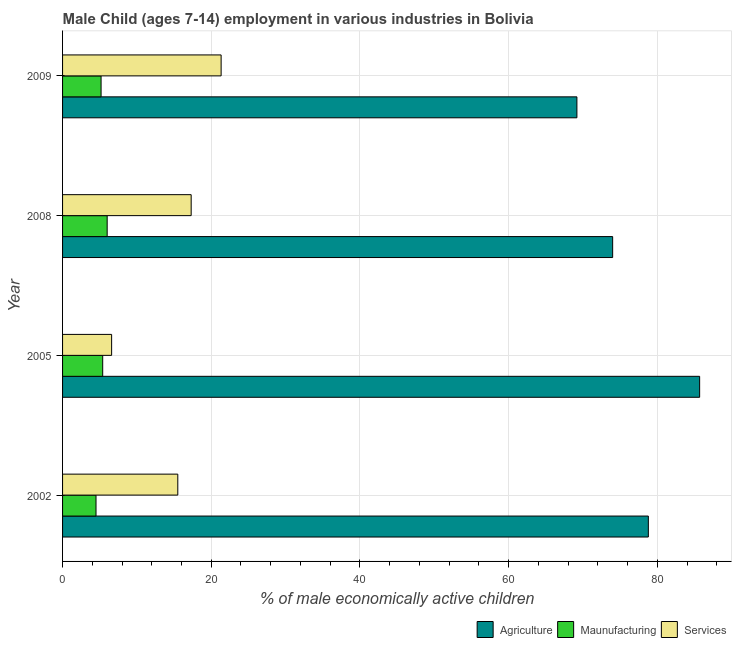How many different coloured bars are there?
Your answer should be very brief. 3. How many groups of bars are there?
Provide a short and direct response. 4. Are the number of bars on each tick of the Y-axis equal?
Offer a terse response. Yes. How many bars are there on the 4th tick from the bottom?
Your response must be concise. 3. What is the label of the 3rd group of bars from the top?
Your response must be concise. 2005. What is the percentage of economically active children in agriculture in 2009?
Your response must be concise. 69.19. Across all years, what is the minimum percentage of economically active children in agriculture?
Offer a very short reply. 69.19. In which year was the percentage of economically active children in agriculture maximum?
Provide a short and direct response. 2005. In which year was the percentage of economically active children in agriculture minimum?
Give a very brief answer. 2009. What is the total percentage of economically active children in services in the graph?
Provide a succinct answer. 60.73. What is the difference between the percentage of economically active children in services in 2002 and that in 2005?
Keep it short and to the point. 8.9. What is the difference between the percentage of economically active children in services in 2009 and the percentage of economically active children in agriculture in 2005?
Your answer should be compact. -64.37. What is the average percentage of economically active children in manufacturing per year?
Your response must be concise. 5.27. In the year 2002, what is the difference between the percentage of economically active children in services and percentage of economically active children in agriculture?
Keep it short and to the point. -63.3. What is the ratio of the percentage of economically active children in manufacturing in 2002 to that in 2008?
Make the answer very short. 0.75. Is the difference between the percentage of economically active children in manufacturing in 2008 and 2009 greater than the difference between the percentage of economically active children in services in 2008 and 2009?
Your answer should be very brief. Yes. What is the difference between the highest and the second highest percentage of economically active children in services?
Provide a short and direct response. 4.03. What is the difference between the highest and the lowest percentage of economically active children in agriculture?
Offer a very short reply. 16.51. Is the sum of the percentage of economically active children in agriculture in 2002 and 2008 greater than the maximum percentage of economically active children in services across all years?
Provide a short and direct response. Yes. What does the 2nd bar from the top in 2009 represents?
Your response must be concise. Maunufacturing. What does the 2nd bar from the bottom in 2009 represents?
Ensure brevity in your answer.  Maunufacturing. Is it the case that in every year, the sum of the percentage of economically active children in agriculture and percentage of economically active children in manufacturing is greater than the percentage of economically active children in services?
Ensure brevity in your answer.  Yes. Are all the bars in the graph horizontal?
Your answer should be compact. Yes. How many years are there in the graph?
Your response must be concise. 4. What is the difference between two consecutive major ticks on the X-axis?
Offer a terse response. 20. Does the graph contain grids?
Ensure brevity in your answer.  Yes. How many legend labels are there?
Your response must be concise. 3. What is the title of the graph?
Your answer should be compact. Male Child (ages 7-14) employment in various industries in Bolivia. Does "Infant(female)" appear as one of the legend labels in the graph?
Keep it short and to the point. No. What is the label or title of the X-axis?
Ensure brevity in your answer.  % of male economically active children. What is the label or title of the Y-axis?
Provide a short and direct response. Year. What is the % of male economically active children of Agriculture in 2002?
Make the answer very short. 78.8. What is the % of male economically active children in Services in 2002?
Provide a succinct answer. 15.5. What is the % of male economically active children of Agriculture in 2005?
Make the answer very short. 85.7. What is the % of male economically active children of Maunufacturing in 2005?
Provide a succinct answer. 5.4. What is the % of male economically active children of Services in 2005?
Provide a short and direct response. 6.6. What is the % of male economically active children of Agriculture in 2009?
Offer a terse response. 69.19. What is the % of male economically active children in Maunufacturing in 2009?
Your response must be concise. 5.18. What is the % of male economically active children of Services in 2009?
Your answer should be very brief. 21.33. Across all years, what is the maximum % of male economically active children of Agriculture?
Keep it short and to the point. 85.7. Across all years, what is the maximum % of male economically active children in Maunufacturing?
Keep it short and to the point. 6. Across all years, what is the maximum % of male economically active children of Services?
Ensure brevity in your answer.  21.33. Across all years, what is the minimum % of male economically active children in Agriculture?
Offer a very short reply. 69.19. What is the total % of male economically active children of Agriculture in the graph?
Offer a terse response. 307.69. What is the total % of male economically active children of Maunufacturing in the graph?
Give a very brief answer. 21.08. What is the total % of male economically active children of Services in the graph?
Provide a succinct answer. 60.73. What is the difference between the % of male economically active children in Agriculture in 2002 and that in 2005?
Offer a very short reply. -6.9. What is the difference between the % of male economically active children in Agriculture in 2002 and that in 2008?
Your answer should be compact. 4.8. What is the difference between the % of male economically active children of Services in 2002 and that in 2008?
Your response must be concise. -1.8. What is the difference between the % of male economically active children in Agriculture in 2002 and that in 2009?
Keep it short and to the point. 9.61. What is the difference between the % of male economically active children in Maunufacturing in 2002 and that in 2009?
Offer a terse response. -0.68. What is the difference between the % of male economically active children of Services in 2002 and that in 2009?
Keep it short and to the point. -5.83. What is the difference between the % of male economically active children of Agriculture in 2005 and that in 2008?
Offer a very short reply. 11.7. What is the difference between the % of male economically active children of Maunufacturing in 2005 and that in 2008?
Your answer should be very brief. -0.6. What is the difference between the % of male economically active children of Services in 2005 and that in 2008?
Offer a terse response. -10.7. What is the difference between the % of male economically active children of Agriculture in 2005 and that in 2009?
Give a very brief answer. 16.51. What is the difference between the % of male economically active children in Maunufacturing in 2005 and that in 2009?
Provide a short and direct response. 0.22. What is the difference between the % of male economically active children of Services in 2005 and that in 2009?
Your answer should be very brief. -14.73. What is the difference between the % of male economically active children in Agriculture in 2008 and that in 2009?
Keep it short and to the point. 4.81. What is the difference between the % of male economically active children of Maunufacturing in 2008 and that in 2009?
Offer a very short reply. 0.82. What is the difference between the % of male economically active children in Services in 2008 and that in 2009?
Provide a short and direct response. -4.03. What is the difference between the % of male economically active children in Agriculture in 2002 and the % of male economically active children in Maunufacturing in 2005?
Provide a short and direct response. 73.4. What is the difference between the % of male economically active children in Agriculture in 2002 and the % of male economically active children in Services in 2005?
Ensure brevity in your answer.  72.2. What is the difference between the % of male economically active children in Maunufacturing in 2002 and the % of male economically active children in Services in 2005?
Keep it short and to the point. -2.1. What is the difference between the % of male economically active children of Agriculture in 2002 and the % of male economically active children of Maunufacturing in 2008?
Offer a very short reply. 72.8. What is the difference between the % of male economically active children in Agriculture in 2002 and the % of male economically active children in Services in 2008?
Ensure brevity in your answer.  61.5. What is the difference between the % of male economically active children in Agriculture in 2002 and the % of male economically active children in Maunufacturing in 2009?
Give a very brief answer. 73.62. What is the difference between the % of male economically active children of Agriculture in 2002 and the % of male economically active children of Services in 2009?
Make the answer very short. 57.47. What is the difference between the % of male economically active children of Maunufacturing in 2002 and the % of male economically active children of Services in 2009?
Your answer should be very brief. -16.83. What is the difference between the % of male economically active children of Agriculture in 2005 and the % of male economically active children of Maunufacturing in 2008?
Keep it short and to the point. 79.7. What is the difference between the % of male economically active children of Agriculture in 2005 and the % of male economically active children of Services in 2008?
Keep it short and to the point. 68.4. What is the difference between the % of male economically active children of Agriculture in 2005 and the % of male economically active children of Maunufacturing in 2009?
Offer a terse response. 80.52. What is the difference between the % of male economically active children in Agriculture in 2005 and the % of male economically active children in Services in 2009?
Make the answer very short. 64.37. What is the difference between the % of male economically active children of Maunufacturing in 2005 and the % of male economically active children of Services in 2009?
Make the answer very short. -15.93. What is the difference between the % of male economically active children in Agriculture in 2008 and the % of male economically active children in Maunufacturing in 2009?
Provide a succinct answer. 68.82. What is the difference between the % of male economically active children in Agriculture in 2008 and the % of male economically active children in Services in 2009?
Your answer should be compact. 52.67. What is the difference between the % of male economically active children of Maunufacturing in 2008 and the % of male economically active children of Services in 2009?
Provide a short and direct response. -15.33. What is the average % of male economically active children in Agriculture per year?
Your answer should be compact. 76.92. What is the average % of male economically active children of Maunufacturing per year?
Ensure brevity in your answer.  5.27. What is the average % of male economically active children in Services per year?
Ensure brevity in your answer.  15.18. In the year 2002, what is the difference between the % of male economically active children in Agriculture and % of male economically active children in Maunufacturing?
Your answer should be very brief. 74.3. In the year 2002, what is the difference between the % of male economically active children of Agriculture and % of male economically active children of Services?
Provide a short and direct response. 63.3. In the year 2002, what is the difference between the % of male economically active children of Maunufacturing and % of male economically active children of Services?
Offer a terse response. -11. In the year 2005, what is the difference between the % of male economically active children of Agriculture and % of male economically active children of Maunufacturing?
Offer a terse response. 80.3. In the year 2005, what is the difference between the % of male economically active children in Agriculture and % of male economically active children in Services?
Give a very brief answer. 79.1. In the year 2008, what is the difference between the % of male economically active children in Agriculture and % of male economically active children in Services?
Provide a succinct answer. 56.7. In the year 2008, what is the difference between the % of male economically active children of Maunufacturing and % of male economically active children of Services?
Your answer should be compact. -11.3. In the year 2009, what is the difference between the % of male economically active children of Agriculture and % of male economically active children of Maunufacturing?
Your response must be concise. 64.01. In the year 2009, what is the difference between the % of male economically active children of Agriculture and % of male economically active children of Services?
Your answer should be very brief. 47.86. In the year 2009, what is the difference between the % of male economically active children of Maunufacturing and % of male economically active children of Services?
Your answer should be compact. -16.15. What is the ratio of the % of male economically active children in Agriculture in 2002 to that in 2005?
Offer a very short reply. 0.92. What is the ratio of the % of male economically active children in Maunufacturing in 2002 to that in 2005?
Your response must be concise. 0.83. What is the ratio of the % of male economically active children in Services in 2002 to that in 2005?
Make the answer very short. 2.35. What is the ratio of the % of male economically active children of Agriculture in 2002 to that in 2008?
Offer a very short reply. 1.06. What is the ratio of the % of male economically active children in Services in 2002 to that in 2008?
Provide a short and direct response. 0.9. What is the ratio of the % of male economically active children in Agriculture in 2002 to that in 2009?
Make the answer very short. 1.14. What is the ratio of the % of male economically active children of Maunufacturing in 2002 to that in 2009?
Ensure brevity in your answer.  0.87. What is the ratio of the % of male economically active children of Services in 2002 to that in 2009?
Give a very brief answer. 0.73. What is the ratio of the % of male economically active children of Agriculture in 2005 to that in 2008?
Keep it short and to the point. 1.16. What is the ratio of the % of male economically active children of Services in 2005 to that in 2008?
Offer a terse response. 0.38. What is the ratio of the % of male economically active children in Agriculture in 2005 to that in 2009?
Your response must be concise. 1.24. What is the ratio of the % of male economically active children in Maunufacturing in 2005 to that in 2009?
Make the answer very short. 1.04. What is the ratio of the % of male economically active children in Services in 2005 to that in 2009?
Make the answer very short. 0.31. What is the ratio of the % of male economically active children of Agriculture in 2008 to that in 2009?
Provide a short and direct response. 1.07. What is the ratio of the % of male economically active children of Maunufacturing in 2008 to that in 2009?
Keep it short and to the point. 1.16. What is the ratio of the % of male economically active children of Services in 2008 to that in 2009?
Provide a short and direct response. 0.81. What is the difference between the highest and the second highest % of male economically active children of Agriculture?
Offer a very short reply. 6.9. What is the difference between the highest and the second highest % of male economically active children of Services?
Provide a short and direct response. 4.03. What is the difference between the highest and the lowest % of male economically active children in Agriculture?
Provide a succinct answer. 16.51. What is the difference between the highest and the lowest % of male economically active children in Maunufacturing?
Give a very brief answer. 1.5. What is the difference between the highest and the lowest % of male economically active children in Services?
Keep it short and to the point. 14.73. 